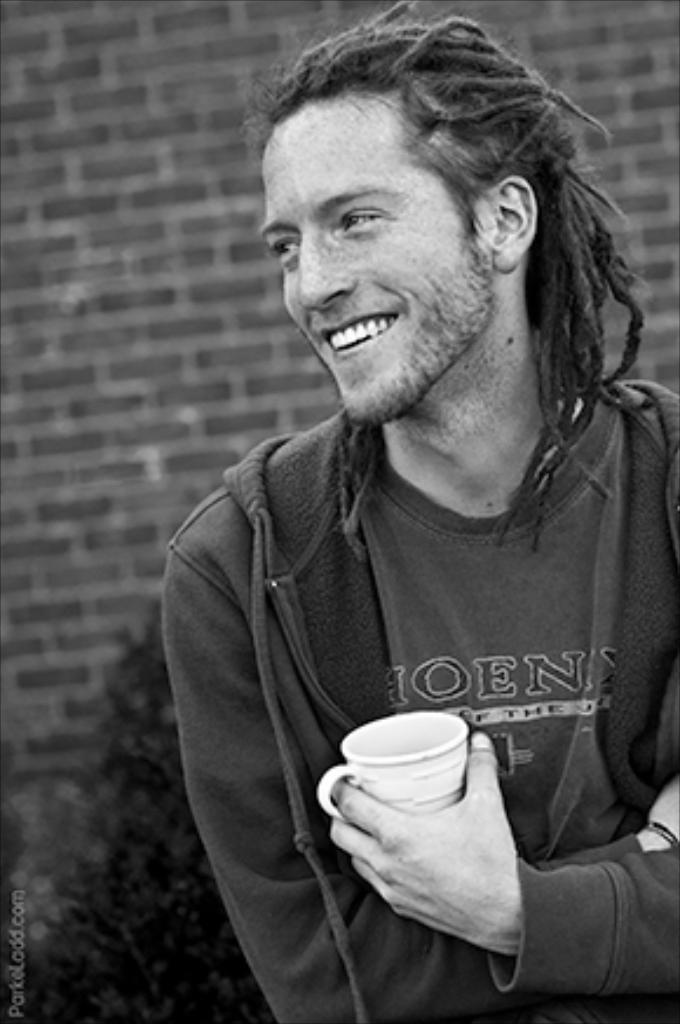Who is present in the image? There is a man in the image. What is the man doing in the image? The man is smiling in the image. What is the man holding in the image? The man is holding a cup in the image. What is the man wearing in the image? The man is wearing a jacket and a t-shirt in the image. What can be seen in the background of the image? There is a wall and plants in the background of the image. What type of business is the man conducting in the image? There is no indication of a business in the image; the man is simply smiling and holding a cup. Can you hear a horn in the image? There is no sound present in the image, so it is not possible to hear a horn. 